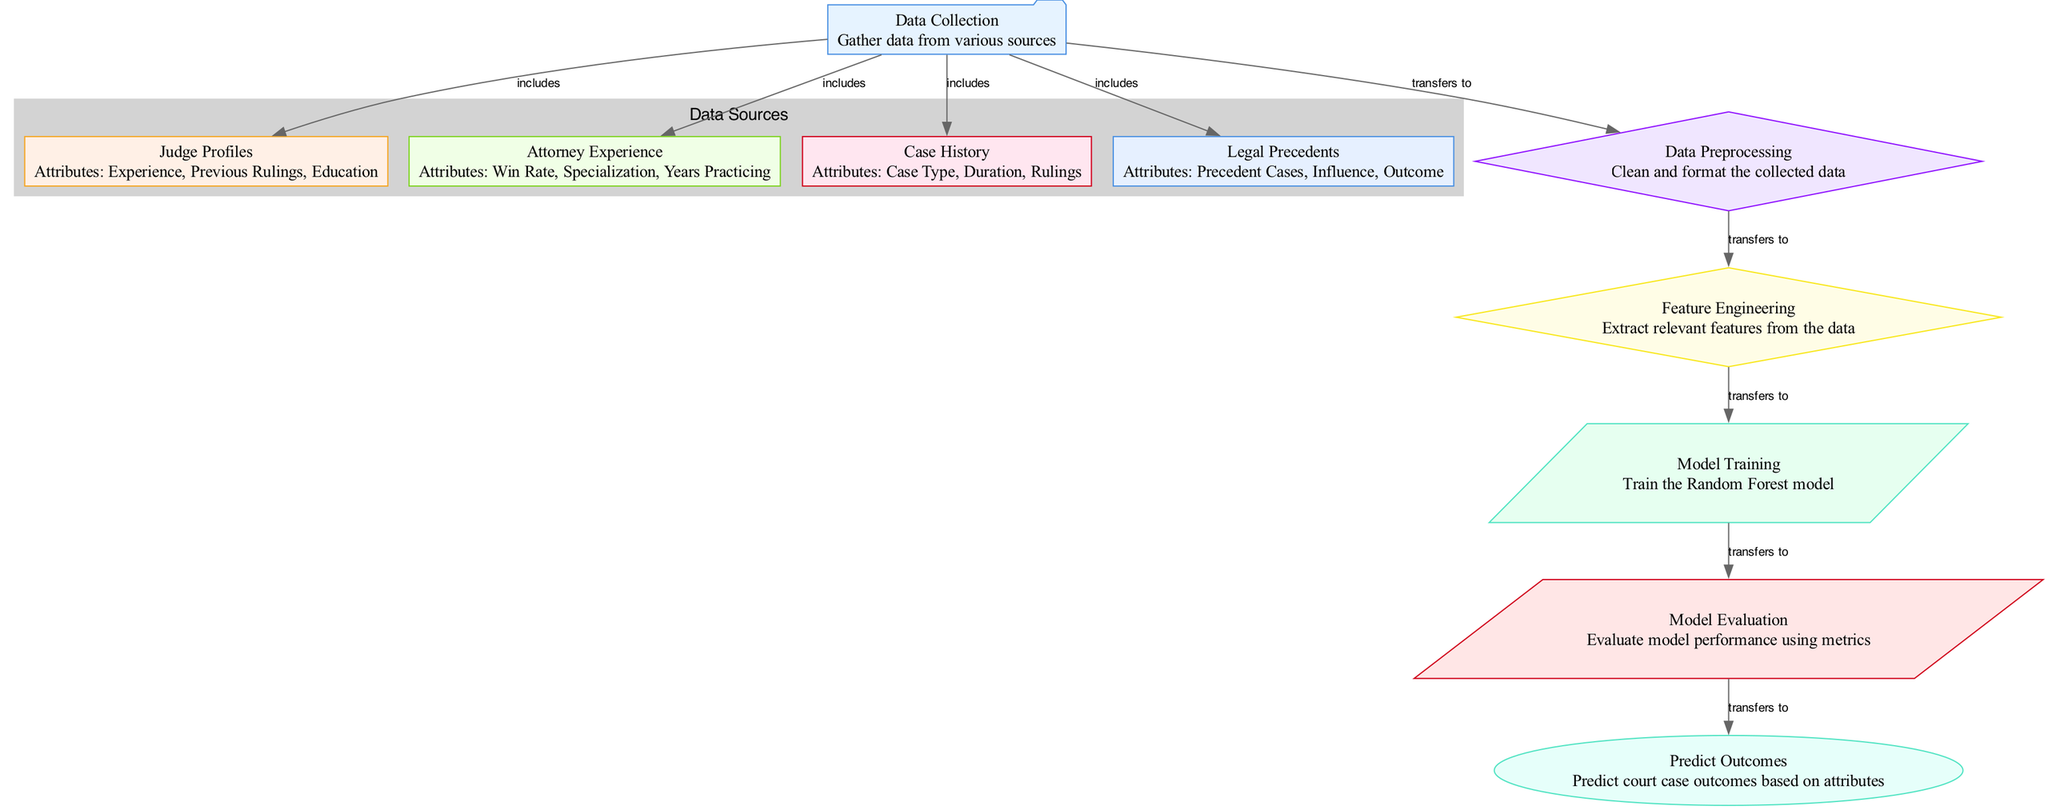What is the first step in the process? The first step is "Data Collection," where various types of data are gathered. This is the starting node in the diagram, indicating its importance in the predictive modeling process.
Answer: Data Collection How many data source nodes are there? The diagram includes four data source nodes: "Judge Profiles," "Attorney Experience," "Case History," and "Legal Precedents." Counting these provides the answer.
Answer: 4 Which type of diagram is used for this model? The diagram is a "Machine Learning Diagram," specifically outlining the process of using a Random Forest model for predicting legal outcomes. This characteristic defines its type.
Answer: Machine Learning Diagram What does "Data Preprocessing" transfer to? "Data Preprocessing" transfers to "Feature Engineering," indicating that the output of preprocessing is the input for feature extraction, demonstrating a clear flow in the process.
Answer: Feature Engineering What type of shape is used for the "Model Evaluation" node? The "Model Evaluation" node is shaped like a parallelogram, which is used for processes in the diagram. This is a specific shape associated with certain types of actions or evaluations.
Answer: Parallelogram What attributes are included in "Attorney Experience"? The attributes for "Attorney Experience" are: Win Rate, Specialization, and Years Practicing. This detailed description gives insight into the factors considered for attorney profiling.
Answer: Win Rate, Specialization, Years Practicing What is the last step in the model? The last step is "Predict Outcomes," which indicates that predictions about court case outcomes are made based on the processed and evaluated features and models. This marks the final stage of the process.
Answer: Predict Outcomes Which node connects directly to "Model Training"? "Feature Engineering" connects directly to "Model Training," showing the progression from feature extraction to model training within the predictive modeling process.
Answer: Feature Engineering How does "Data Collection" connect to "Data Preprocessing"? "Data Collection" transfers to "Data Preprocessing," indicating that the collected data is then cleaned and formatted before feature extraction and analysis. This describes the relationship between the two nodes.
Answer: Transfers to 